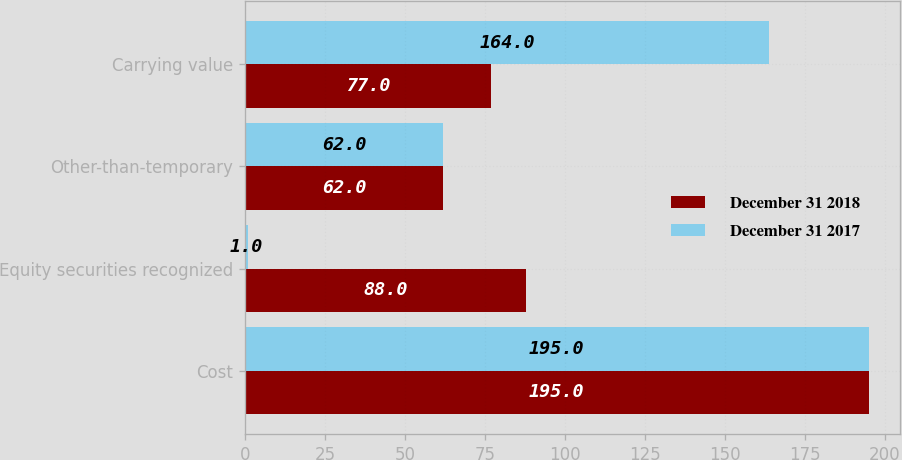Convert chart to OTSL. <chart><loc_0><loc_0><loc_500><loc_500><stacked_bar_chart><ecel><fcel>Cost<fcel>Equity securities recognized<fcel>Other-than-temporary<fcel>Carrying value<nl><fcel>December 31 2018<fcel>195<fcel>88<fcel>62<fcel>77<nl><fcel>December 31 2017<fcel>195<fcel>1<fcel>62<fcel>164<nl></chart> 